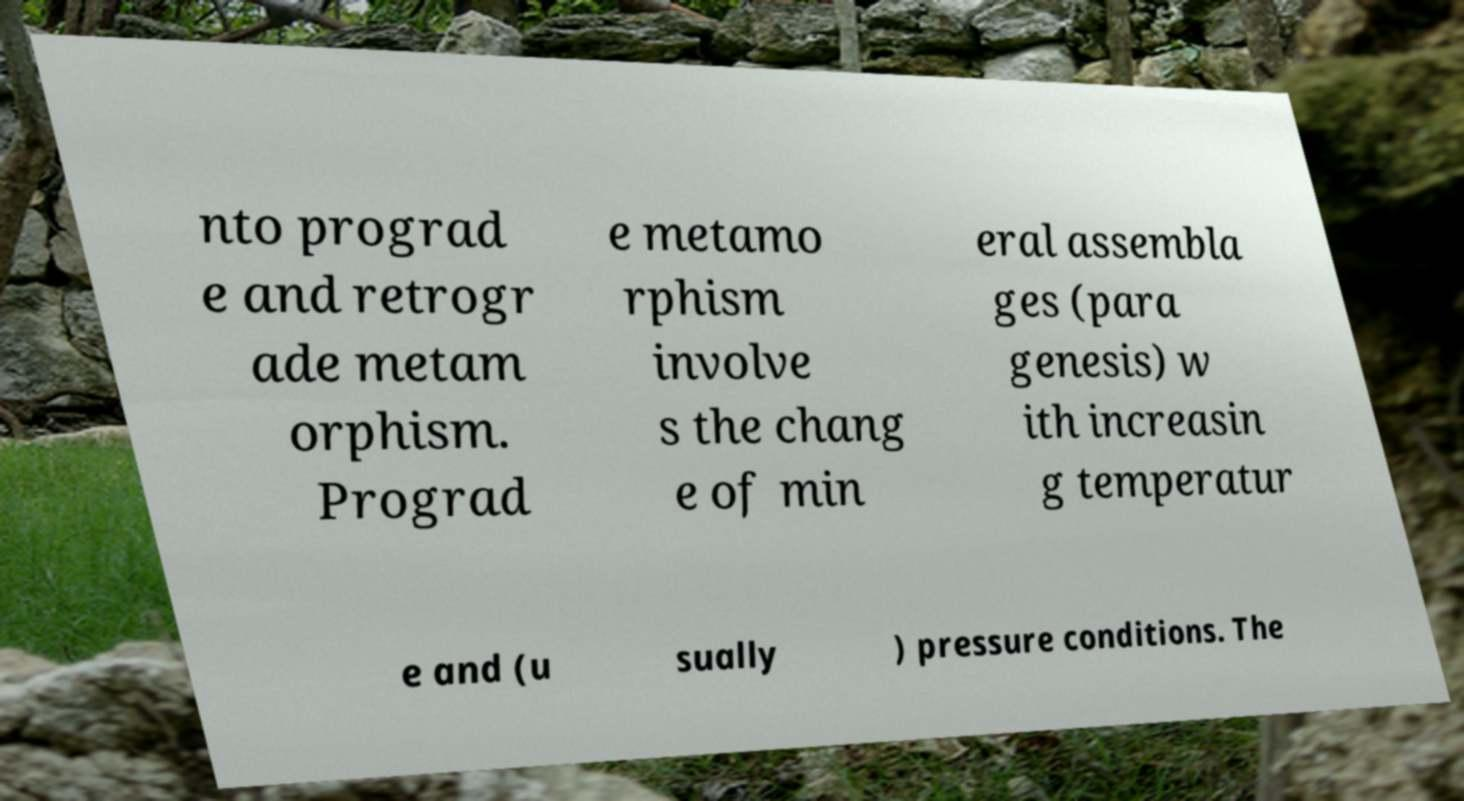What messages or text are displayed in this image? I need them in a readable, typed format. nto prograd e and retrogr ade metam orphism. Prograd e metamo rphism involve s the chang e of min eral assembla ges (para genesis) w ith increasin g temperatur e and (u sually ) pressure conditions. The 